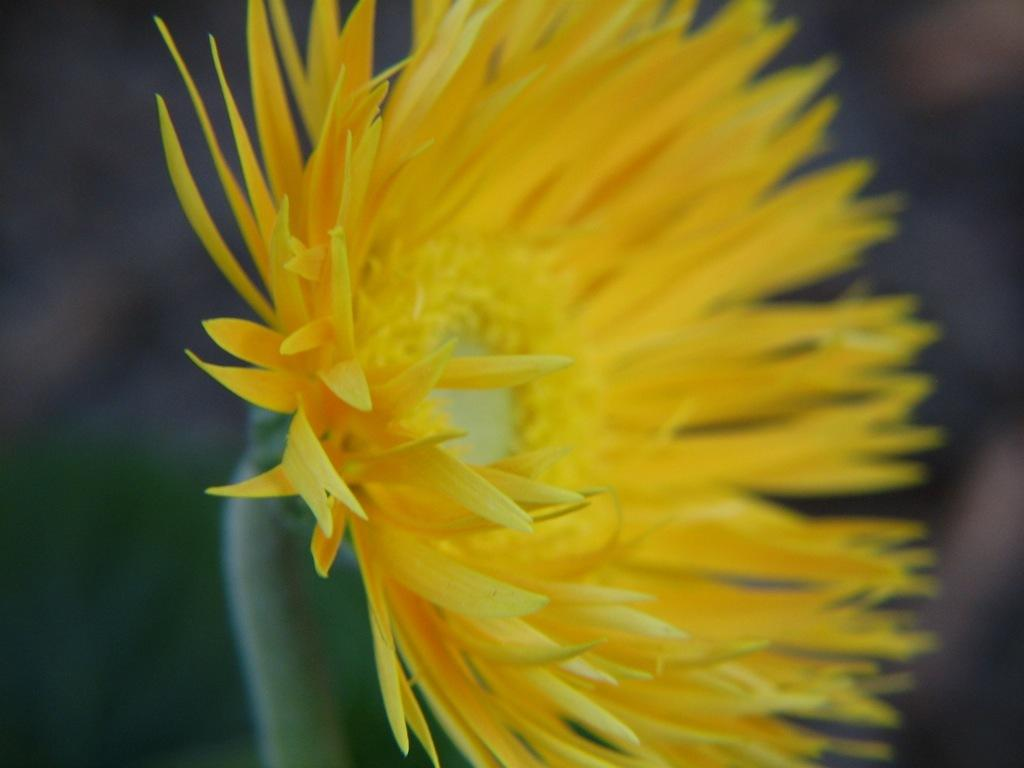What is the main subject of the image? There is a flower in the image. How many houses are visible in the image? There are no houses present in the image; it only features a flower. What type of ornament is hanging from the flower in the image? There is no ornament hanging from the flower in the image; only the flower is present. 